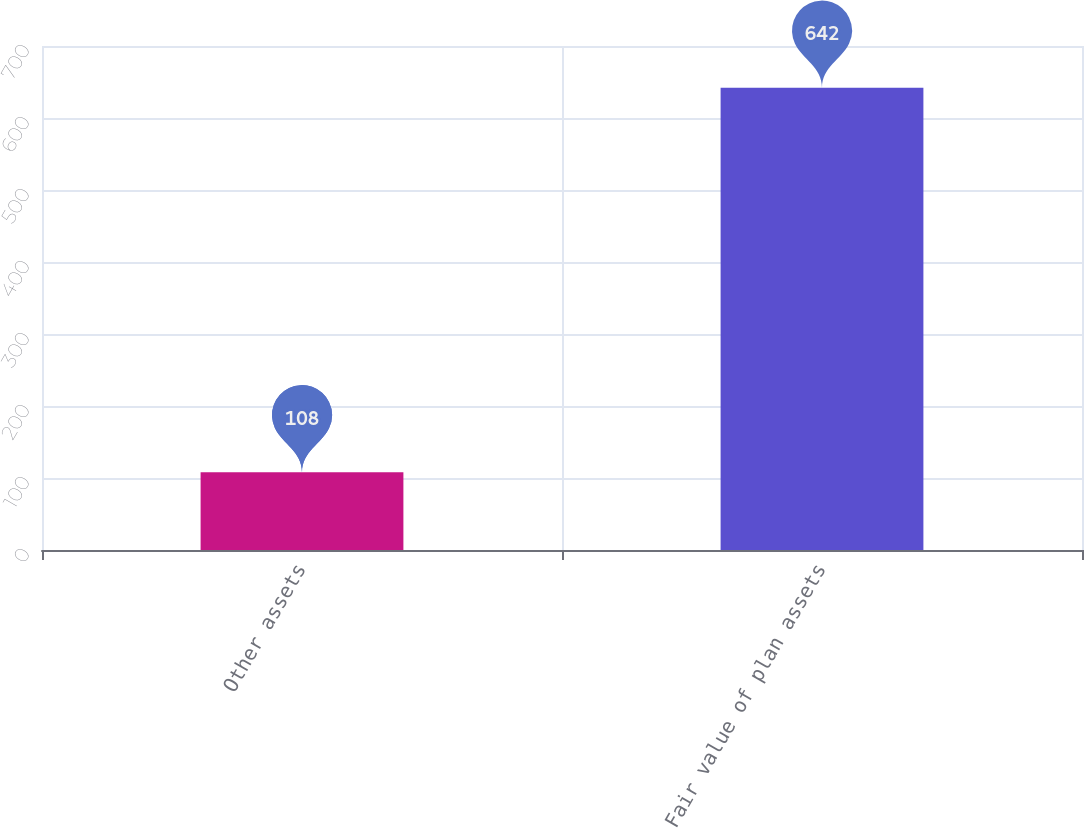Convert chart. <chart><loc_0><loc_0><loc_500><loc_500><bar_chart><fcel>Other assets<fcel>Fair value of plan assets<nl><fcel>108<fcel>642<nl></chart> 